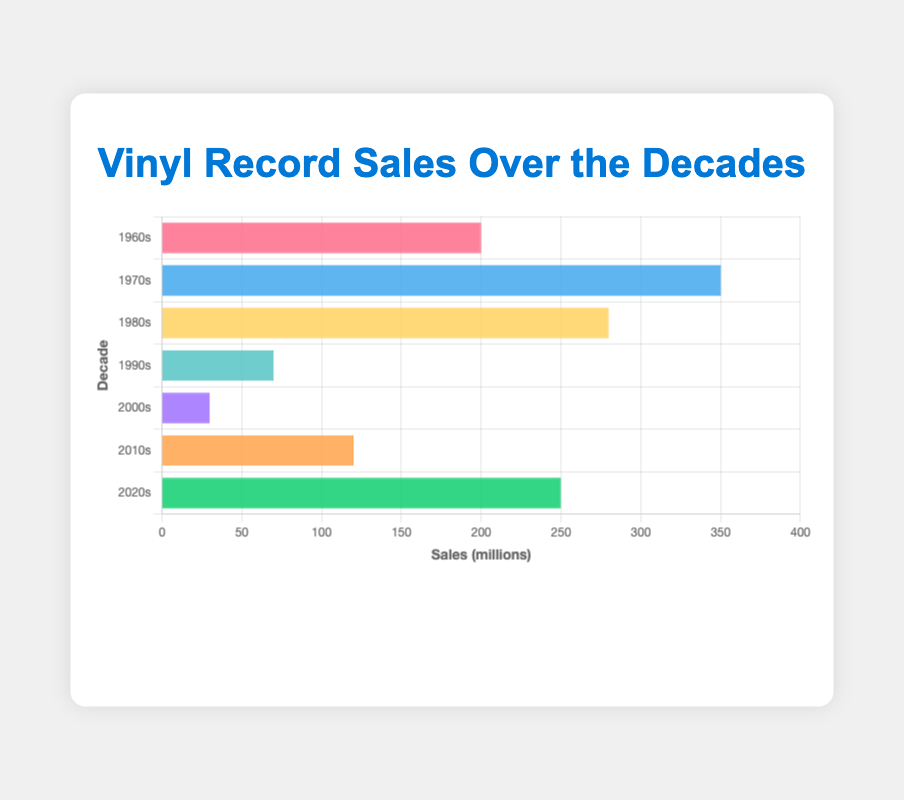Which decade had the highest vinyl record sales? The highest bar in the chart represents the 1970s with 350 million sales. By comparing the lengths of all bars, the 1970s bar is the longest.
Answer: 1970s Which decade had the lowest vinyl record sales? The lowest bar in the chart represents the 2000s with 30 million sales. By comparing the lengths of all bars, the 2000s bar is the shortest.
Answer: 2000s How many decades had sales greater than 100 million? The bars representing the 1960s, 1970s, 1980s, and 2020s all exceed 100 million sales. Count these bursts to find four such decades.
Answer: 4 What is the total vinyl record sales for the 1980s and 2020s combined? The sales in the 1980s are 280 million and in the 2020s are 250 million. Sum these numbers: 280 + 250 = 530 million.
Answer: 530 million How much more were the vinyl record sales in the 1970s compared to the 1990s? The sales in the 1970s were 350 million and in the 1990s were 70 million. Subtract the 1990s sales from the 1970s sales: 350 - 70 = 280 million.
Answer: 280 million Which two decades had the closest vinyl record sales? By comparing the lengths of the bars, the closest sales numbers are for the 1960s (200 million) and the 2020s (250 million). The difference is 50 million, smaller than any other pair.
Answer: 1960s and 2020s In which decade did vinyl record sales first drop below 100 million? Observing the sequence, the 1990s is the first decade where the bar drops below the 100 million mark, with 70 million sales.
Answer: 1990s What is the average vinyl record sales of all listed decades? Sum all sales: 200 + 350 + 280 + 70 + 30 + 120 + 250 = 1300 million. There are 7 decades: 1300 / 7 ≈ 185.71 million.
Answer: 185.71 million What is the difference between the highest and lowest decade sales? The highest sales are in the 1970s (350 million) and the lowest in the 2000s (30 million). Subtract the lowest from the highest: 350 - 30 = 320 million.
Answer: 320 million Which decade had the greatest increase in vinyl record sales from the previous decade? Comparing sequential bars, the largest increase is from the 2000s to the 2010s (30 million to 120 million), an increase of 90 million sales.
Answer: 2000s to 2010s 